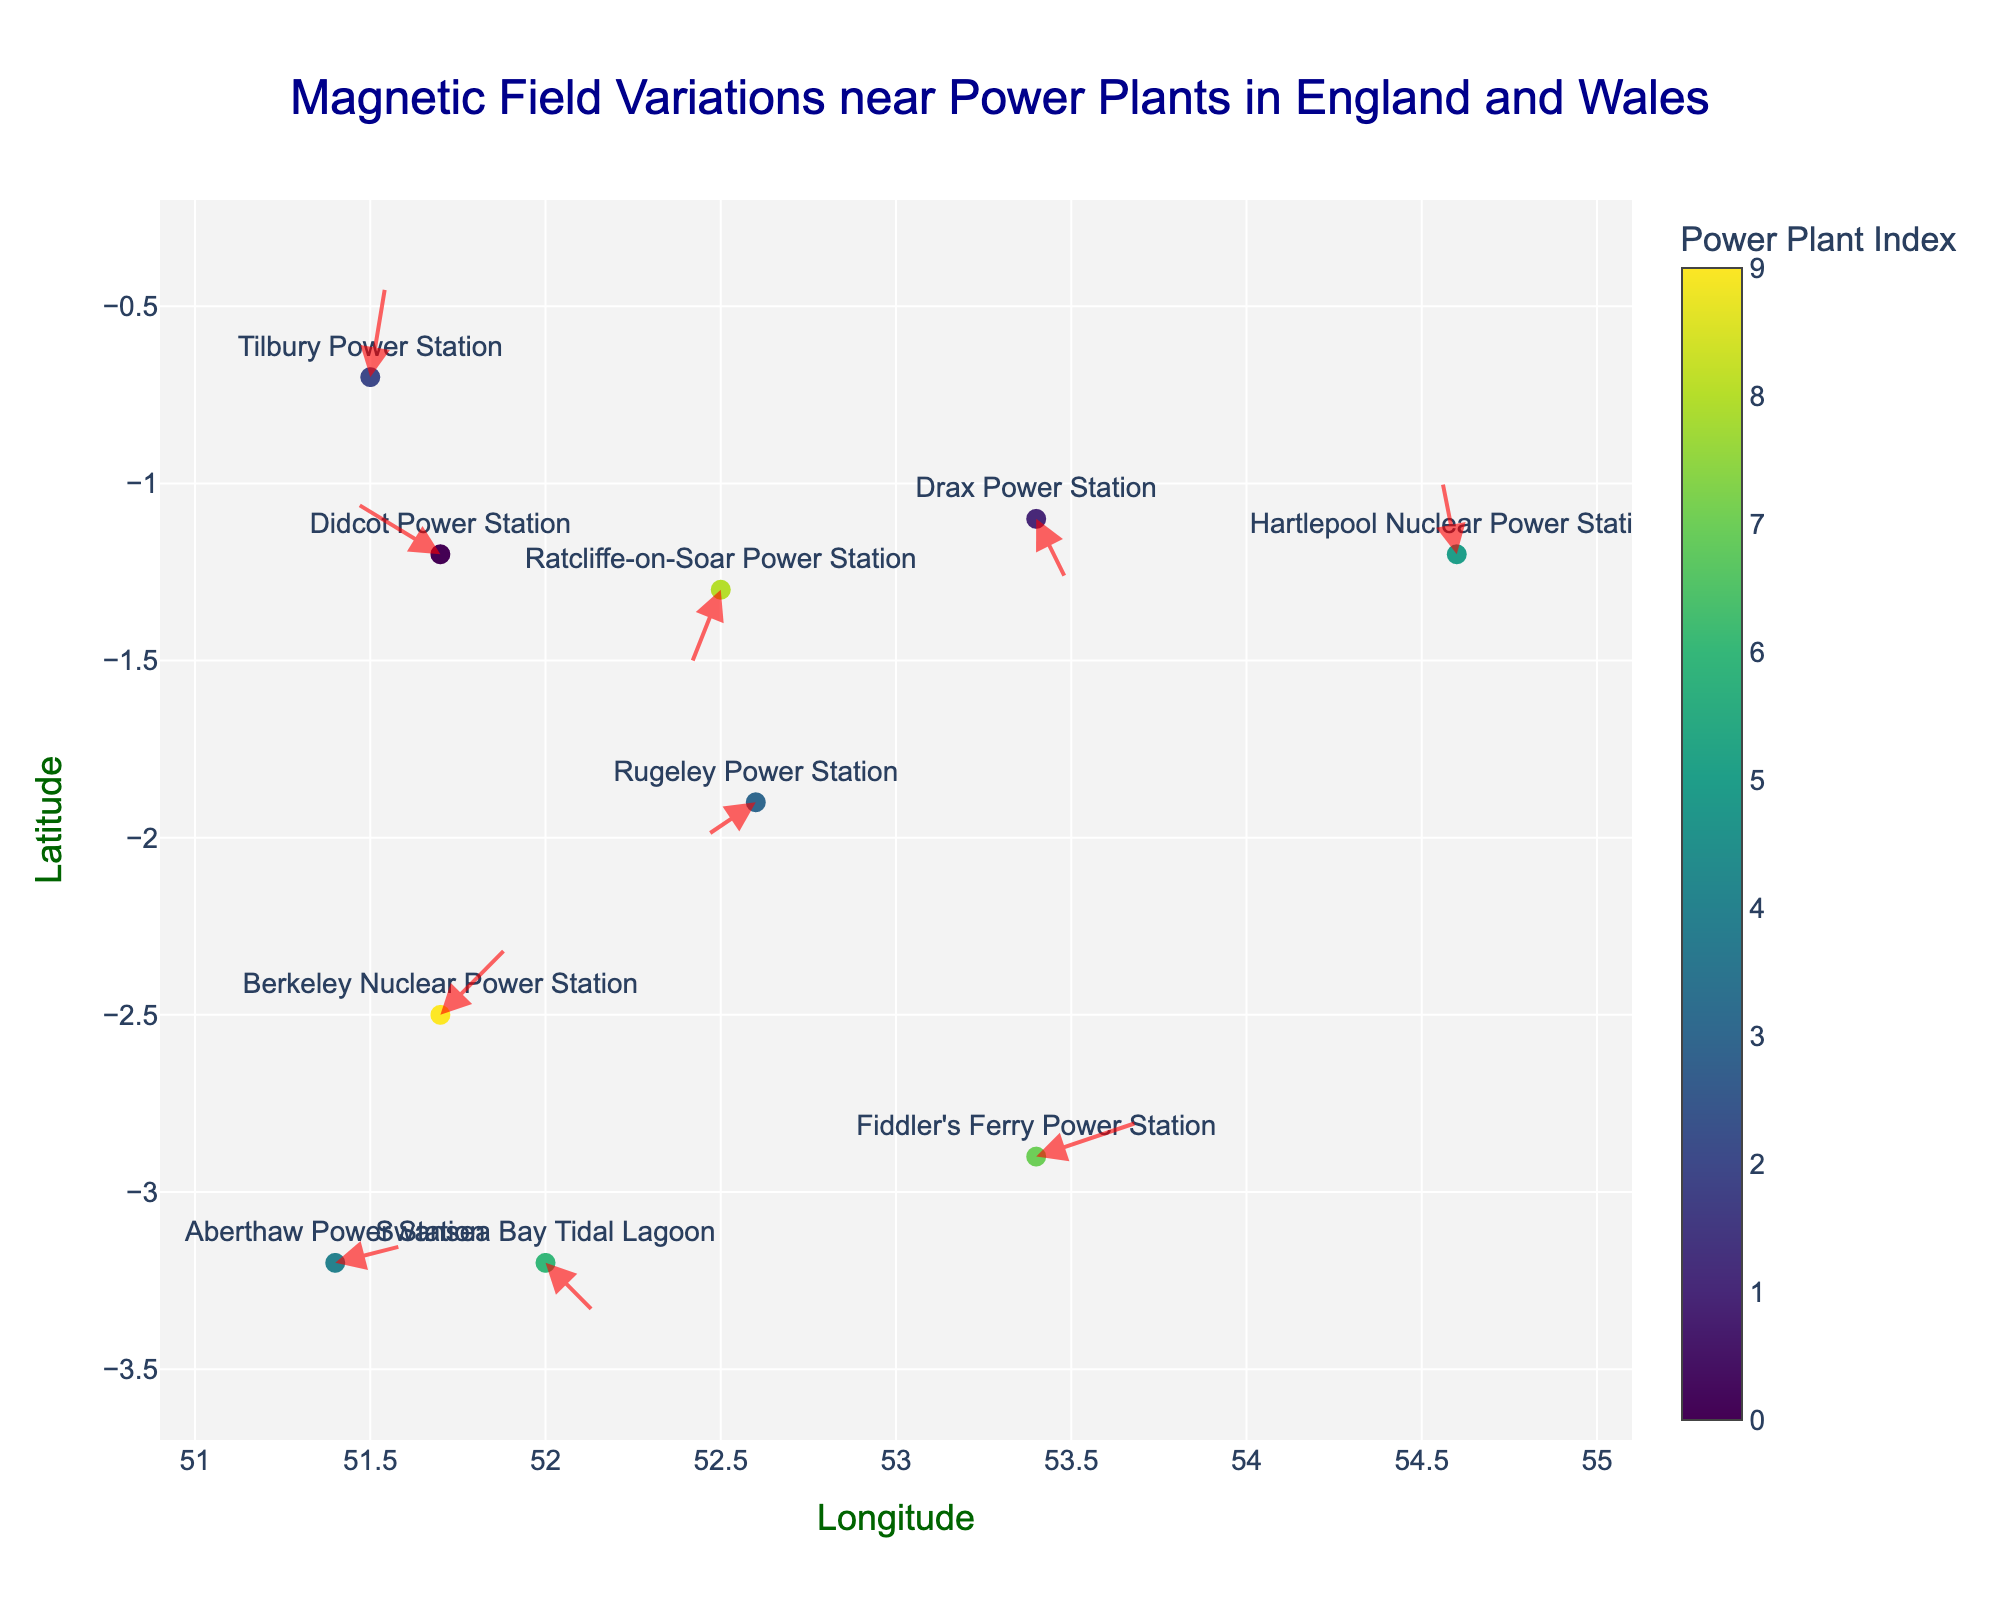What is the title of the figure? The title of the figure is usually displayed prominently at the top of the plot. In this case, it is: "Magnetic Field Variations near Power Plants in England and Wales"
Answer: Magnetic Field Variations near Power Plants in England and Wales What are the axes titles in the figure? The axes titles are typically labeled along the axes. The x-axis title is "Longitude" and the y-axis title is "Latitude"
Answer: Longitude, Latitude How many power plants are represented in the figure? Each marker in the plot represents a power plant and there are corresponding labels for each. Counting the labeled points gives us a total of 10 power plants
Answer: 10 Which power plant has the arrow pointing in the direction (to the left and up)? To find this, we check which arrow is pointing left (negative x-direction) and up (positive y-direction). The Didcot Power Station at (51.7, -1.2) has an arrow with a u of -0.5 (left) and v of 0.3 (up)
Answer: Didcot Power Station What is the general direction of the arrow near Aberthaw Power Station? The direction of an arrow can be determined by the components u and v. For Aberthaw Power Station, with (u,v) as (0.4, 0.1), the arrow generally points right (positive u) and slightly up (positive v)
Answer: Right and slightly up Which power plant shows the largest magnitude of magnetic field variation? The magnitude of variation is found by √(u² + v²). Fiddler's Ferry Power Station with (u,v) as (0.6, 0.2) has the largest magnitude: √(0.6² + 0.2²) = √(0.36 + 0.04) = √0.4 ≈ 0.63
Answer: Fiddler's Ferry Power Station Identify two power plants where the magnetic field variations point in the negative x-direction Arrows pointing left have a negative x-component (u). By checking each power plant, Didcot Power Station (u = -0.5) and Rugeley Power Station (u = -0.3) meet this criteria
Answer: Didcot Power Station and Rugeley Power Station Which power plant's magnetic field variation points most directly downward? The direction is most downward when the y-component (v) is most negative. Ratcliffe-on-Soar Power Station with (u,v) as (-0.2, -0.5) has the strongest downward y-component
Answer: Ratcliffe-on-Soar Power Station What is the combined x-component (u) of the magnetic field variations at the power plants in Wales? Sum the x-components (u) of Aberthaw Power Station (u = 0.4) and Swansea Bay Tidal Lagoon (u = 0.3): 0.4 + 0.3 = 0.7
Answer: 0.7 Compare the arrow lengths of Drax Power Station and Hartlepool Nuclear Power Station. Which is longer? Compute the magnitude of each arrow: 
Drax Power Station: √(0.2² + -0.4²) = √(0.04 + 0.16) = √0.20 ≈ 0.45 
Hartlepool Nuclear Power Station: √(-0.1² + 0.5²) = √(0.01 + 0.25) = √0.26 ≈ 0.51 
Hartlepool Nuclear Power Station has the longer arrow, hence longer magnetic field variation
Answer: Hartlepool Nuclear Power Station 